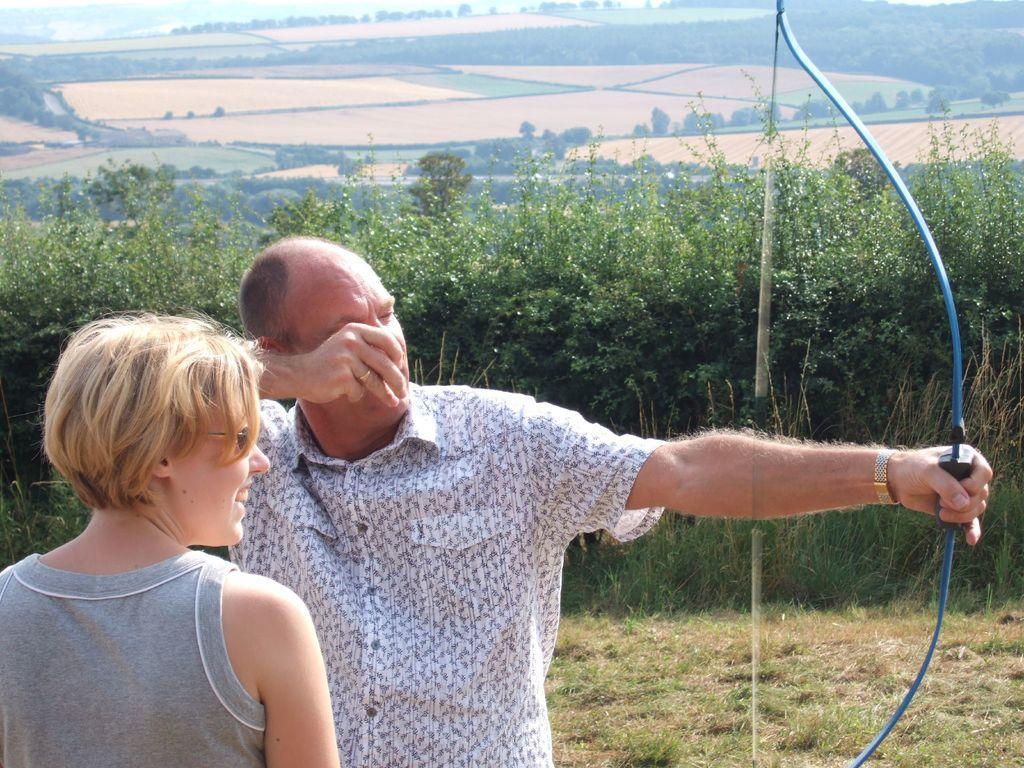Could you give a brief overview of what you see in this image? In the foreground of this image, there is a man in grey T shirt and a man in white shirt holding a bow in his hand. In the background, there is grass, plants, greenery, land and the sky on the top. 